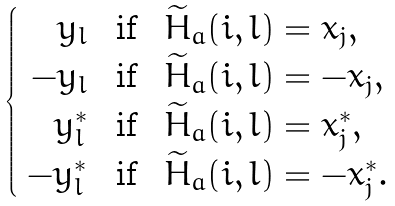Convert formula to latex. <formula><loc_0><loc_0><loc_500><loc_500>\begin{cases} \begin{array} { r l l } y _ { l } & \text { if } & \widetilde { H } _ { a } ( i , l ) = x _ { j } , \\ - y _ { l } & \text { if } & \widetilde { H } _ { a } ( i , l ) = - x _ { j } , \\ y _ { l } ^ { * } & \text { if } & \widetilde { H } _ { a } ( i , l ) = x _ { j } ^ { * } , \\ - y _ { l } ^ { * } & \text { if } & \widetilde { H } _ { a } ( i , l ) = - x _ { j } ^ { * } . \end{array} \end{cases}</formula> 